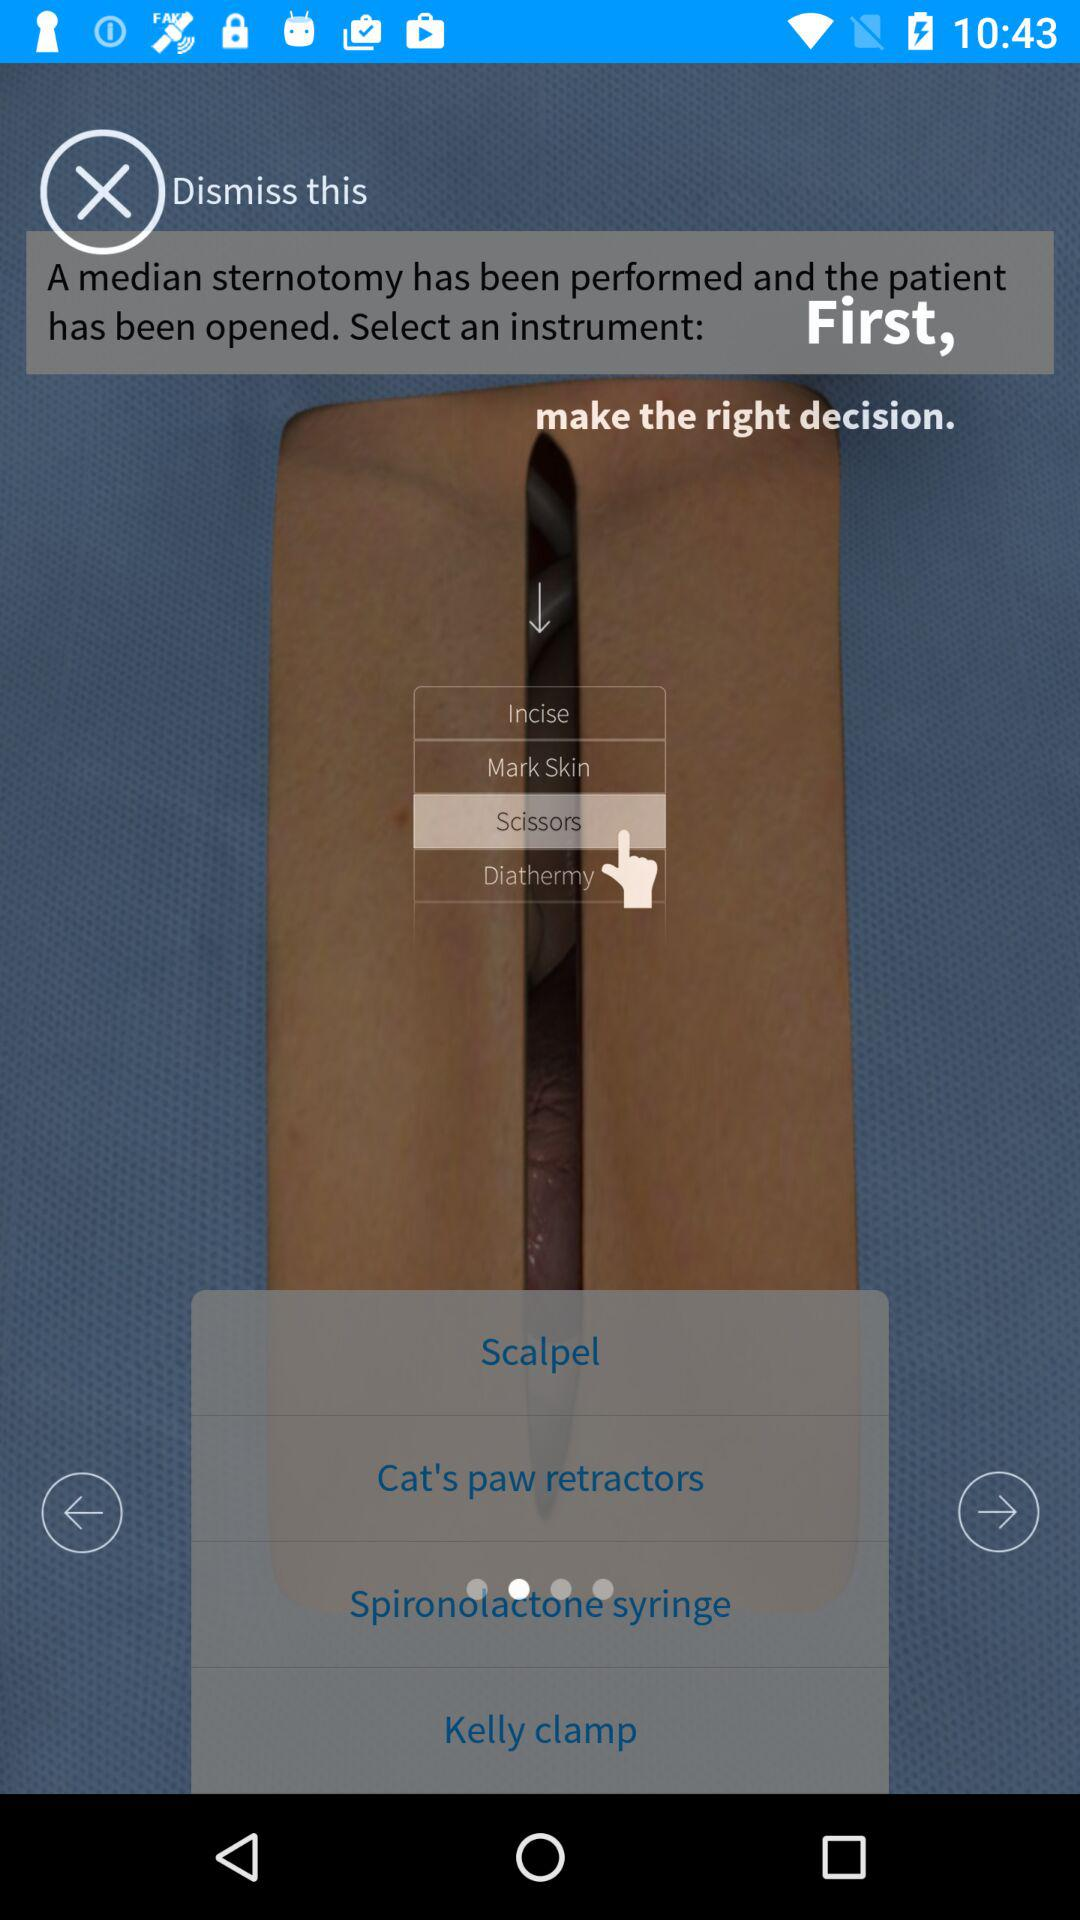Which option is selected? The selected option is "Scissors". 